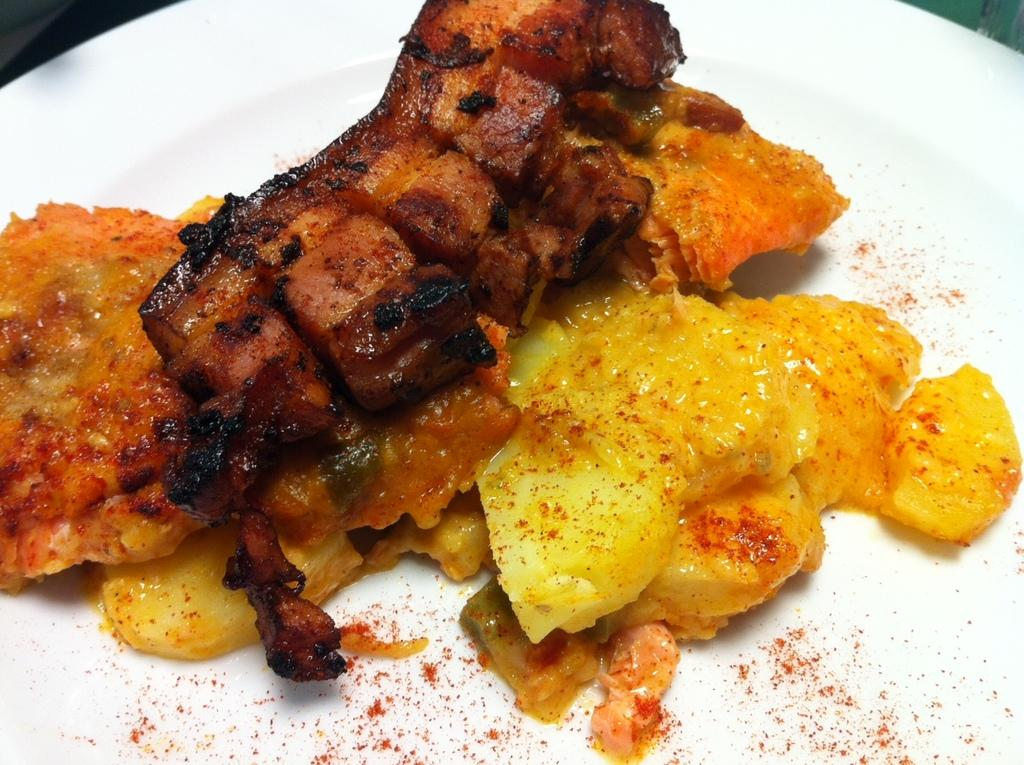What is the main subject of the image? There is a food item in the image. How is the food item presented? The food item is on a white platter. Where is the food item located in relation to the image? The food item is in the foreground of the image. Can you see a flock of animals grazing on the slope in the wilderness in the image? No, there are no animals or wilderness present in the image; it features a food item on a white platter in the foreground. 